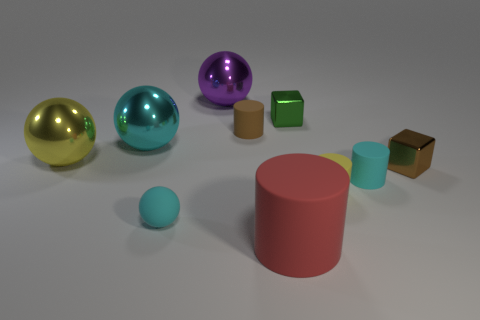Subtract all small matte cylinders. How many cylinders are left? 1 Subtract all purple cylinders. Subtract all cyan balls. How many cylinders are left? 4 Subtract all spheres. How many objects are left? 6 Add 8 metal cubes. How many metal cubes exist? 10 Subtract 0 cyan blocks. How many objects are left? 10 Subtract all big yellow spheres. Subtract all purple things. How many objects are left? 8 Add 8 big purple metal spheres. How many big purple metal spheres are left? 9 